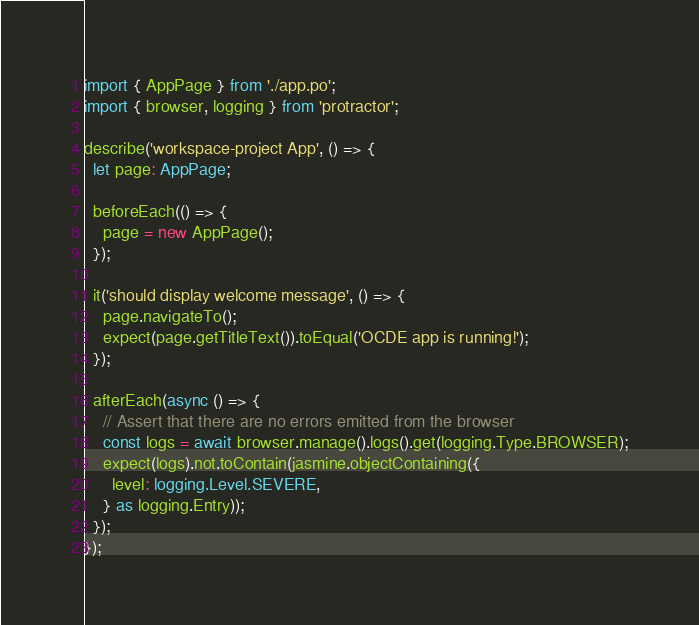Convert code to text. <code><loc_0><loc_0><loc_500><loc_500><_TypeScript_>import { AppPage } from './app.po';
import { browser, logging } from 'protractor';

describe('workspace-project App', () => {
  let page: AppPage;

  beforeEach(() => {
    page = new AppPage();
  });

  it('should display welcome message', () => {
    page.navigateTo();
    expect(page.getTitleText()).toEqual('OCDE app is running!');
  });

  afterEach(async () => {
    // Assert that there are no errors emitted from the browser
    const logs = await browser.manage().logs().get(logging.Type.BROWSER);
    expect(logs).not.toContain(jasmine.objectContaining({
      level: logging.Level.SEVERE,
    } as logging.Entry));
  });
});
</code> 